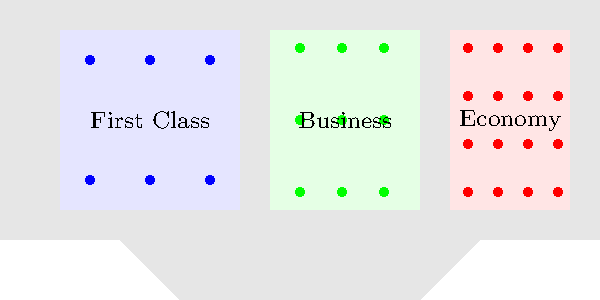If the airplane has 6 seats in First Class, 9 seats in Business Class, and 16 seats in Economy Class, how many total passengers can the plane accommodate? Let's count the seats in each section of the plane:

1. First Class (blue dots):
   - There are 6 seats (2 rows of 3 seats each)

2. Business Class (green dots):
   - There are 9 seats (3 rows of 3 seats each)

3. Economy Class (red dots):
   - There are 16 seats (4 rows of 4 seats each)

To find the total number of passengers, we add up all the seats:

$$ \text{Total passengers} = \text{First Class} + \text{Business Class} + \text{Economy Class} $$
$$ \text{Total passengers} = 6 + 9 + 16 $$
$$ \text{Total passengers} = 31 $$

Therefore, the plane can accommodate 31 passengers in total.
Answer: 31 passengers 